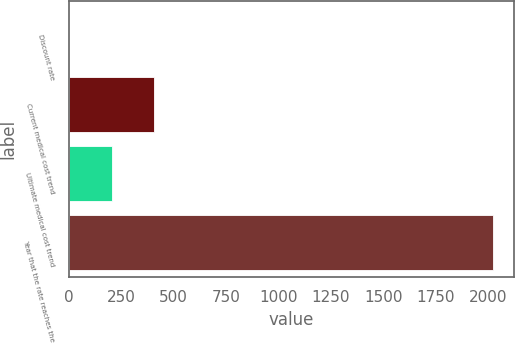Convert chart to OTSL. <chart><loc_0><loc_0><loc_500><loc_500><bar_chart><fcel>Discount rate<fcel>Current medical cost trend<fcel>Ultimate medical cost trend<fcel>Year that the rate reaches the<nl><fcel>4.15<fcel>407.91<fcel>206.03<fcel>2023<nl></chart> 